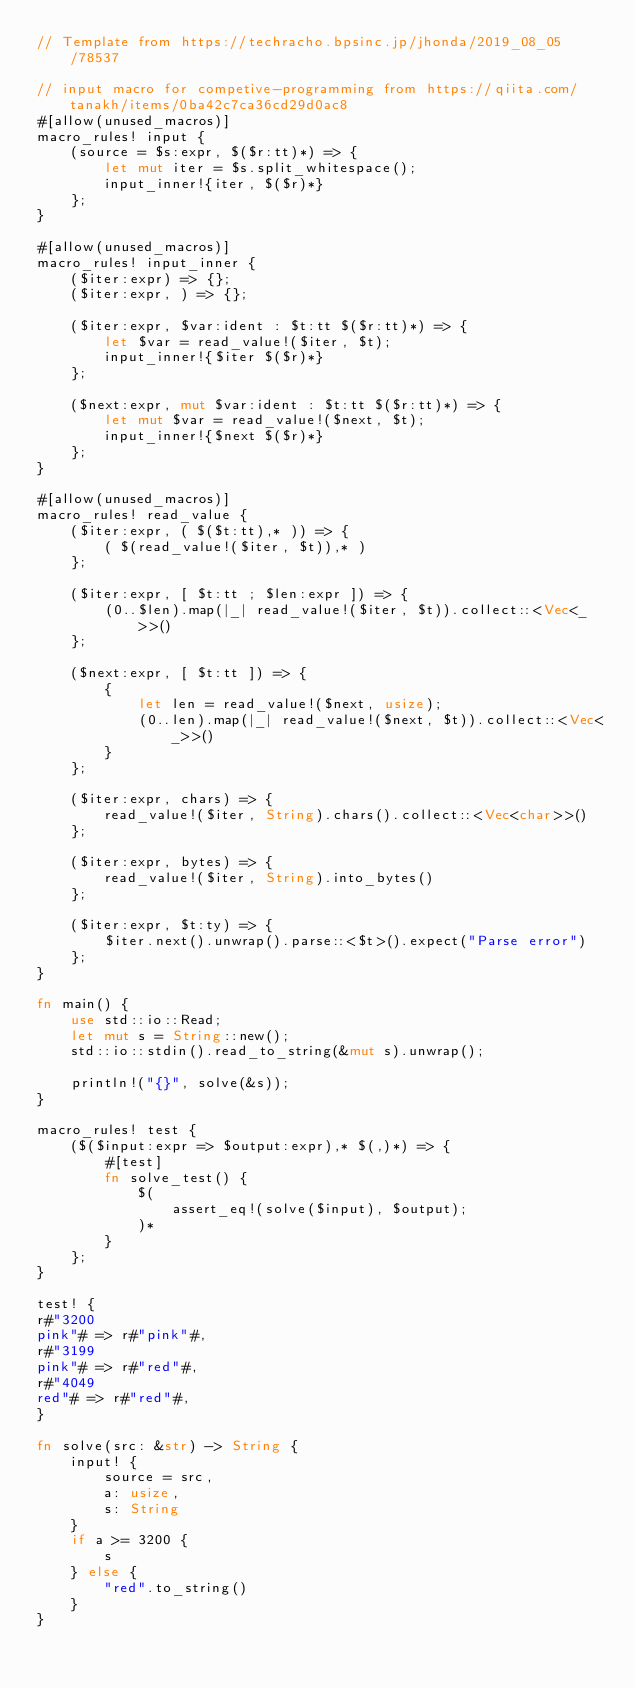Convert code to text. <code><loc_0><loc_0><loc_500><loc_500><_Rust_>// Template from https://techracho.bpsinc.jp/jhonda/2019_08_05/78537

// input macro for competive-programming from https://qiita.com/tanakh/items/0ba42c7ca36cd29d0ac8
#[allow(unused_macros)]
macro_rules! input {
    (source = $s:expr, $($r:tt)*) => {
        let mut iter = $s.split_whitespace();
        input_inner!{iter, $($r)*}
    };
}

#[allow(unused_macros)]
macro_rules! input_inner {
    ($iter:expr) => {};
    ($iter:expr, ) => {};

    ($iter:expr, $var:ident : $t:tt $($r:tt)*) => {
        let $var = read_value!($iter, $t);
        input_inner!{$iter $($r)*}
    };

    ($next:expr, mut $var:ident : $t:tt $($r:tt)*) => {
        let mut $var = read_value!($next, $t);
        input_inner!{$next $($r)*}
    };
}

#[allow(unused_macros)]
macro_rules! read_value {
    ($iter:expr, ( $($t:tt),* )) => {
        ( $(read_value!($iter, $t)),* )
    };

    ($iter:expr, [ $t:tt ; $len:expr ]) => {
        (0..$len).map(|_| read_value!($iter, $t)).collect::<Vec<_>>()
    };

    ($next:expr, [ $t:tt ]) => {
        {
            let len = read_value!($next, usize);
            (0..len).map(|_| read_value!($next, $t)).collect::<Vec<_>>()
        }
    };

    ($iter:expr, chars) => {
        read_value!($iter, String).chars().collect::<Vec<char>>()
    };

    ($iter:expr, bytes) => {
        read_value!($iter, String).into_bytes()
    };

    ($iter:expr, $t:ty) => {
        $iter.next().unwrap().parse::<$t>().expect("Parse error")
    };
}

fn main() {
    use std::io::Read;
    let mut s = String::new();
    std::io::stdin().read_to_string(&mut s).unwrap();

    println!("{}", solve(&s));
}

macro_rules! test {
    ($($input:expr => $output:expr),* $(,)*) => {
        #[test]
        fn solve_test() {
            $(
                assert_eq!(solve($input), $output);
            )*
        }
    };
}

test! {
r#"3200
pink"# => r#"pink"#,
r#"3199
pink"# => r#"red"#,
r#"4049
red"# => r#"red"#,
}

fn solve(src: &str) -> String {
    input! {
        source = src,
        a: usize,
        s: String
    }
    if a >= 3200 {
        s
    } else {
        "red".to_string()
    }
}</code> 